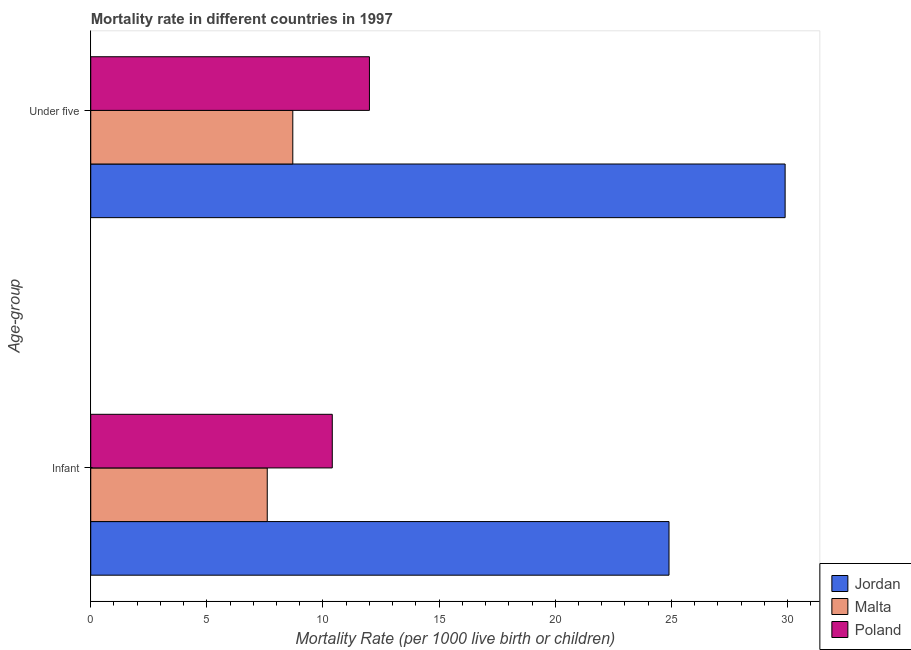How many different coloured bars are there?
Offer a terse response. 3. Are the number of bars per tick equal to the number of legend labels?
Keep it short and to the point. Yes. How many bars are there on the 1st tick from the top?
Your answer should be compact. 3. What is the label of the 1st group of bars from the top?
Provide a short and direct response. Under five. Across all countries, what is the maximum under-5 mortality rate?
Make the answer very short. 29.9. Across all countries, what is the minimum under-5 mortality rate?
Give a very brief answer. 8.7. In which country was the under-5 mortality rate maximum?
Give a very brief answer. Jordan. In which country was the infant mortality rate minimum?
Offer a terse response. Malta. What is the total infant mortality rate in the graph?
Make the answer very short. 42.9. What is the difference between the infant mortality rate in Jordan and that in Poland?
Your answer should be compact. 14.5. What is the average under-5 mortality rate per country?
Provide a succinct answer. 16.87. What is the difference between the under-5 mortality rate and infant mortality rate in Jordan?
Your response must be concise. 5. What is the ratio of the infant mortality rate in Malta to that in Jordan?
Your answer should be very brief. 0.31. Is the under-5 mortality rate in Jordan less than that in Malta?
Your answer should be very brief. No. In how many countries, is the infant mortality rate greater than the average infant mortality rate taken over all countries?
Your answer should be very brief. 1. What does the 1st bar from the top in Under five represents?
Offer a terse response. Poland. What does the 2nd bar from the bottom in Under five represents?
Your answer should be very brief. Malta. Are all the bars in the graph horizontal?
Offer a terse response. Yes. Does the graph contain grids?
Keep it short and to the point. No. Where does the legend appear in the graph?
Keep it short and to the point. Bottom right. How many legend labels are there?
Offer a very short reply. 3. How are the legend labels stacked?
Keep it short and to the point. Vertical. What is the title of the graph?
Provide a succinct answer. Mortality rate in different countries in 1997. What is the label or title of the X-axis?
Give a very brief answer. Mortality Rate (per 1000 live birth or children). What is the label or title of the Y-axis?
Offer a very short reply. Age-group. What is the Mortality Rate (per 1000 live birth or children) of Jordan in Infant?
Ensure brevity in your answer.  24.9. What is the Mortality Rate (per 1000 live birth or children) of Poland in Infant?
Your answer should be compact. 10.4. What is the Mortality Rate (per 1000 live birth or children) in Jordan in Under five?
Make the answer very short. 29.9. Across all Age-group, what is the maximum Mortality Rate (per 1000 live birth or children) in Jordan?
Ensure brevity in your answer.  29.9. Across all Age-group, what is the maximum Mortality Rate (per 1000 live birth or children) in Malta?
Your response must be concise. 8.7. Across all Age-group, what is the minimum Mortality Rate (per 1000 live birth or children) of Jordan?
Make the answer very short. 24.9. Across all Age-group, what is the minimum Mortality Rate (per 1000 live birth or children) in Malta?
Offer a terse response. 7.6. What is the total Mortality Rate (per 1000 live birth or children) in Jordan in the graph?
Your answer should be very brief. 54.8. What is the total Mortality Rate (per 1000 live birth or children) in Poland in the graph?
Provide a succinct answer. 22.4. What is the average Mortality Rate (per 1000 live birth or children) in Jordan per Age-group?
Your answer should be very brief. 27.4. What is the average Mortality Rate (per 1000 live birth or children) of Malta per Age-group?
Your answer should be compact. 8.15. What is the average Mortality Rate (per 1000 live birth or children) of Poland per Age-group?
Provide a succinct answer. 11.2. What is the difference between the Mortality Rate (per 1000 live birth or children) in Jordan and Mortality Rate (per 1000 live birth or children) in Malta in Under five?
Your answer should be compact. 21.2. What is the ratio of the Mortality Rate (per 1000 live birth or children) of Jordan in Infant to that in Under five?
Your response must be concise. 0.83. What is the ratio of the Mortality Rate (per 1000 live birth or children) of Malta in Infant to that in Under five?
Offer a very short reply. 0.87. What is the ratio of the Mortality Rate (per 1000 live birth or children) of Poland in Infant to that in Under five?
Your answer should be compact. 0.87. What is the difference between the highest and the second highest Mortality Rate (per 1000 live birth or children) in Jordan?
Your answer should be compact. 5. What is the difference between the highest and the second highest Mortality Rate (per 1000 live birth or children) of Malta?
Your answer should be very brief. 1.1. 